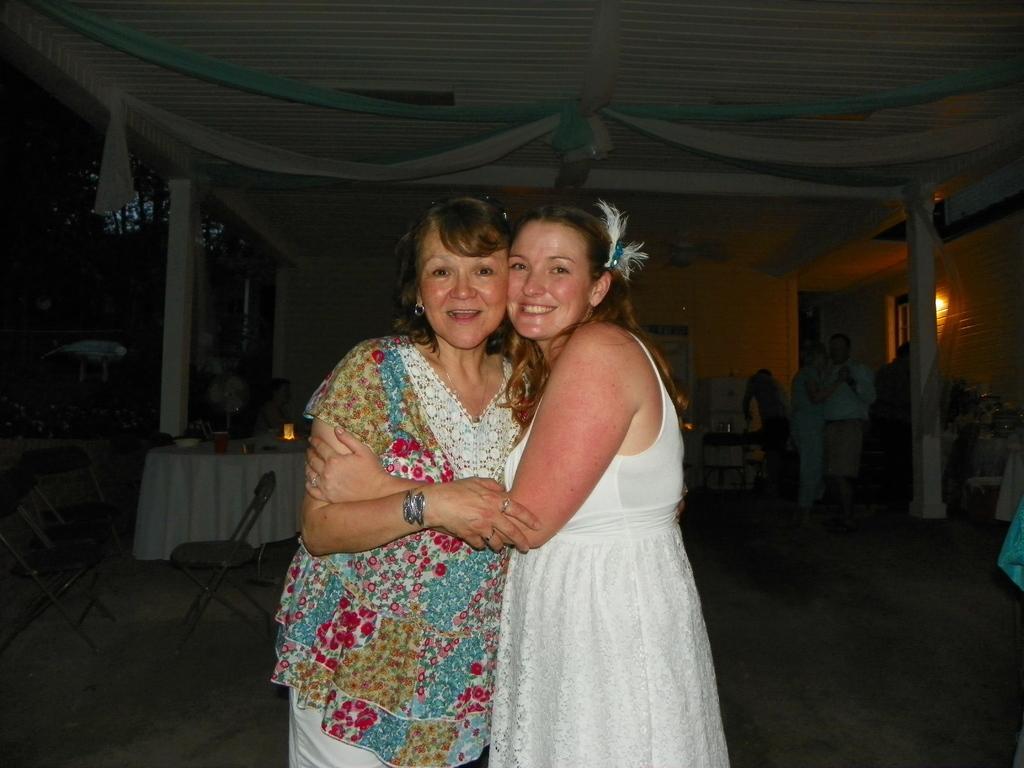Could you give a brief overview of what you see in this image? In this image there are two girls who are holding each others hand. In the background there is a table on which there are bowls and lights. On the left side there are chairs on the ground. On the right side there is a filter through which water is filled. At the top there are clothes. In the background there are few people standing on the floor. There is a light to the wall on the right side. 